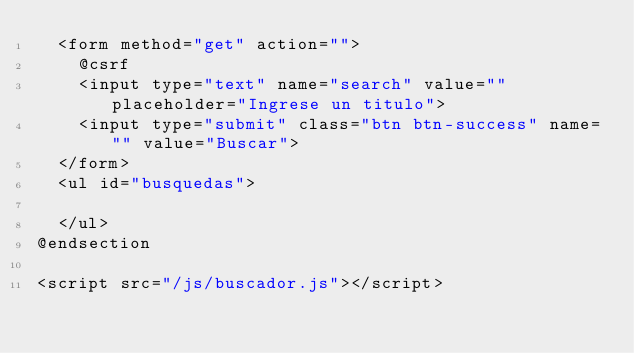<code> <loc_0><loc_0><loc_500><loc_500><_PHP_>  <form method="get" action="">
    @csrf
    <input type="text" name="search" value="" placeholder="Ingrese un titulo">
    <input type="submit" class="btn btn-success" name="" value="Buscar">
  </form>
  <ul id="busquedas">

  </ul>
@endsection

<script src="/js/buscador.js"></script>
</code> 